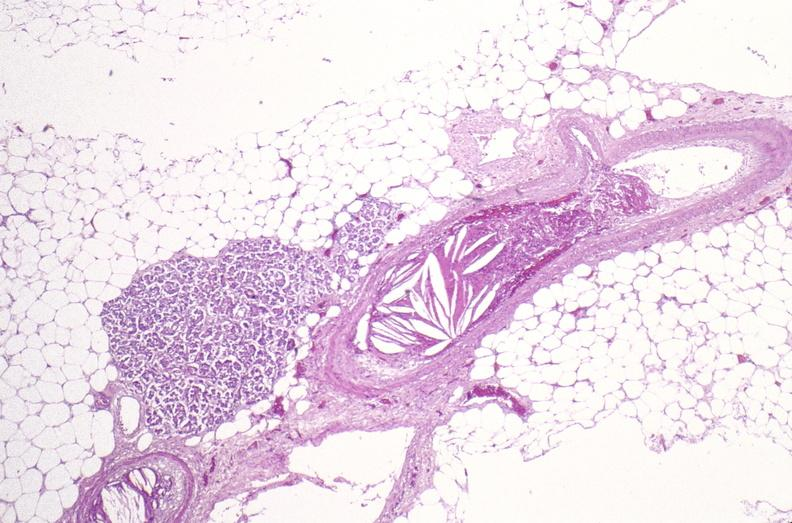what does this image show?
Answer the question using a single word or phrase. Atherosclerotic emboli 